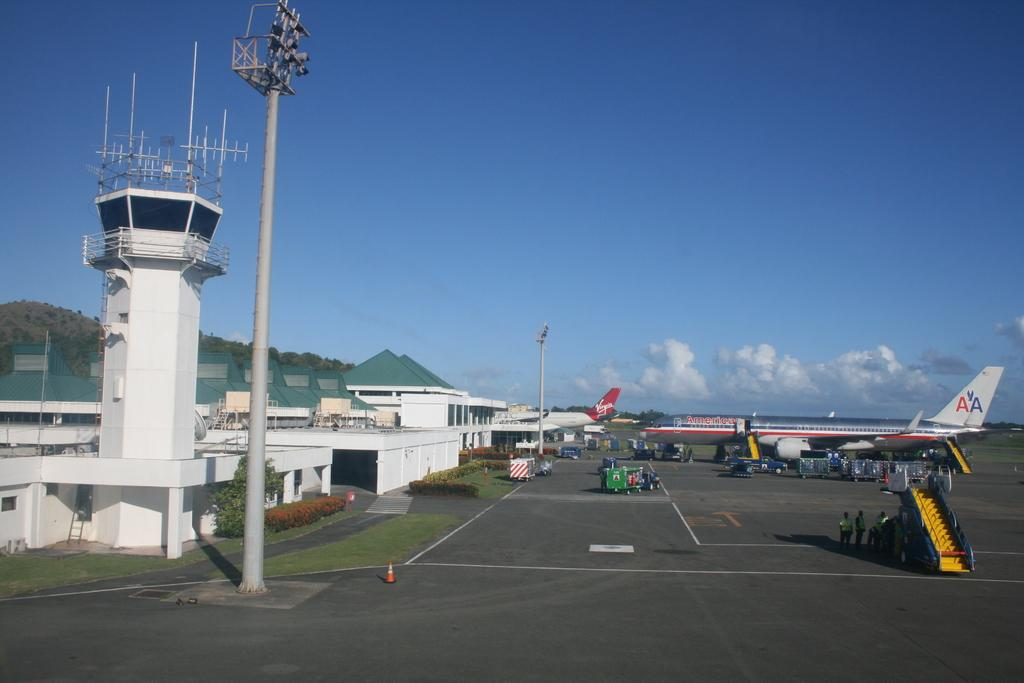<image>
Present a compact description of the photo's key features. a small airport with planes from Virgin and AA parked in front 